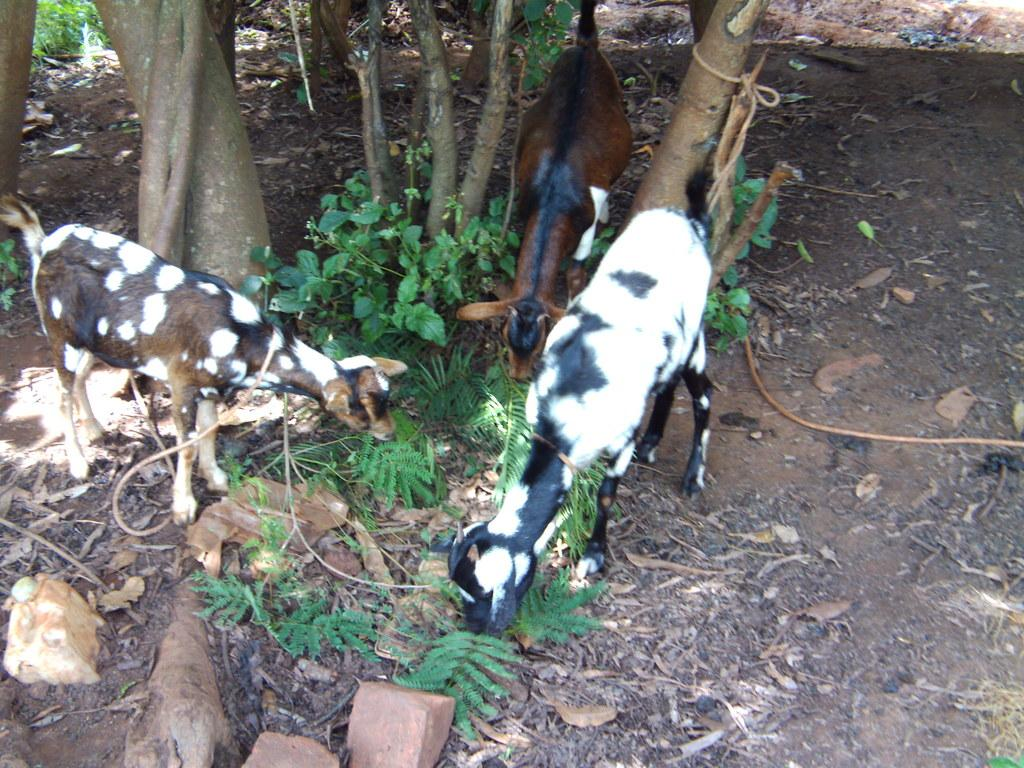How many goats can be seen in the image? There are three goats in the image. What is located at the bottom of the image? Rocks are present at the bottom of the image. What type of vegetation can be seen on the ground? Dried leaves are visible on the ground. What is in the middle of the image? There are plants in the middle of the image. What can be seen in the background of the image? Trees are present in the background of the image. What type of government is depicted in the image? There is no depiction of a government in the image; it features three goats, rocks, dried leaves, plants, and trees. 